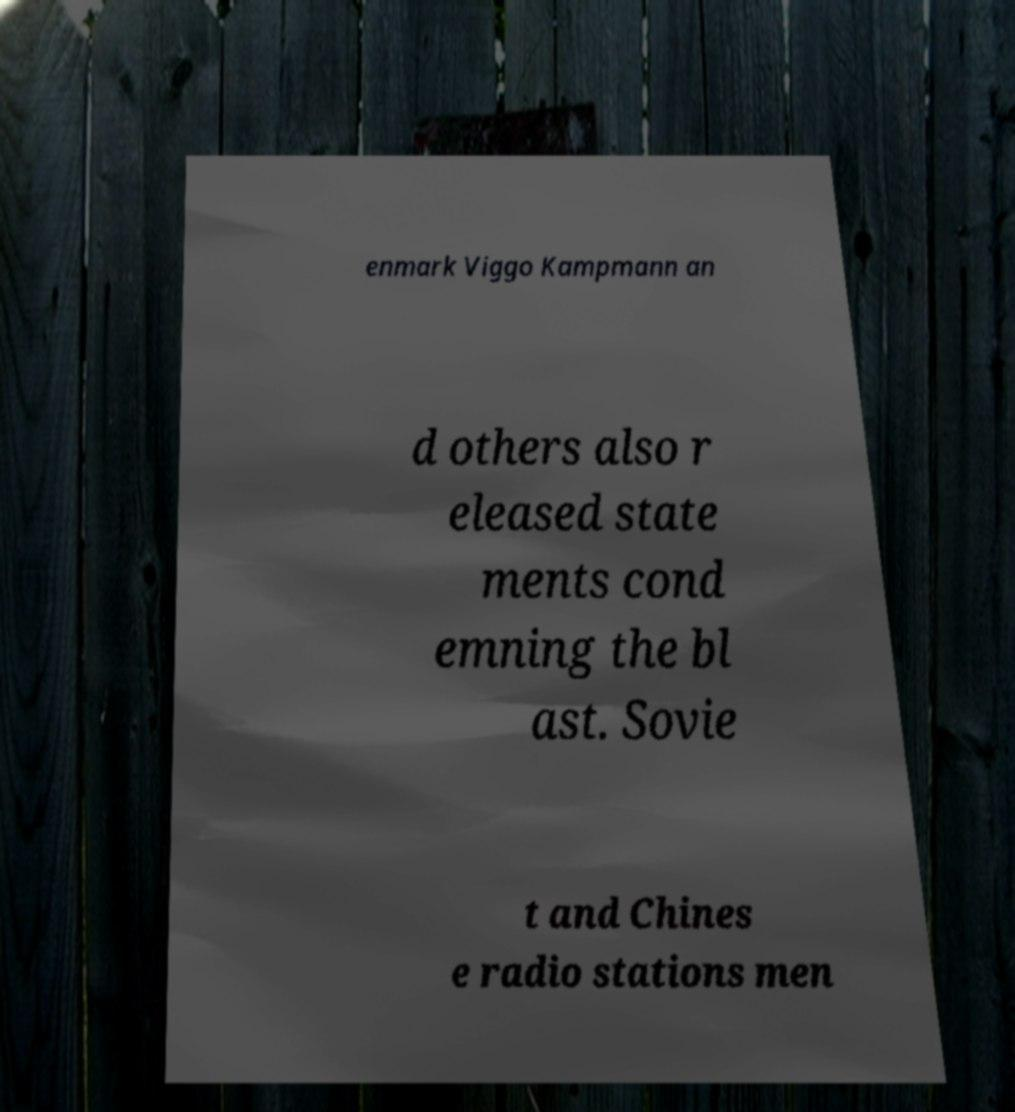For documentation purposes, I need the text within this image transcribed. Could you provide that? enmark Viggo Kampmann an d others also r eleased state ments cond emning the bl ast. Sovie t and Chines e radio stations men 